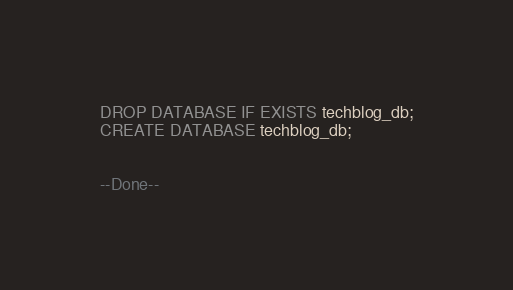<code> <loc_0><loc_0><loc_500><loc_500><_SQL_>DROP DATABASE IF EXISTS techblog_db;
CREATE DATABASE techblog_db;


--Done--</code> 